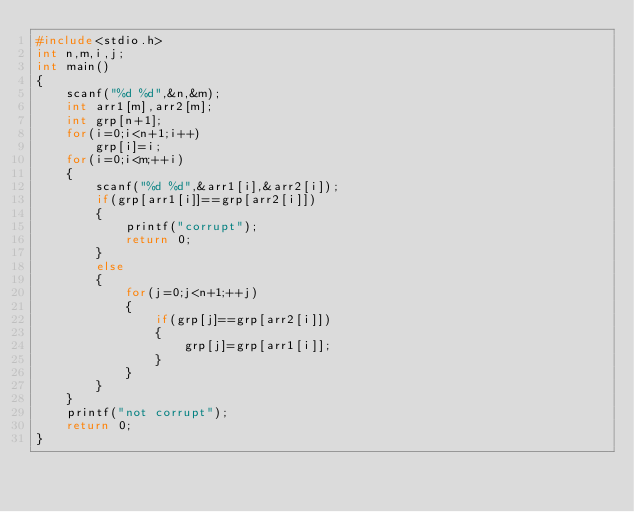<code> <loc_0><loc_0><loc_500><loc_500><_C++_>#include<stdio.h>
int n,m,i,j;
int main()
{
	scanf("%d %d",&n,&m);
	int arr1[m],arr2[m];
	int grp[n+1];
	for(i=0;i<n+1;i++)
		grp[i]=i;
	for(i=0;i<m;++i)
	{
		scanf("%d %d",&arr1[i],&arr2[i]);
		if(grp[arr1[i]]==grp[arr2[i]])
		{
			printf("corrupt");
			return 0;
		}
		else
		{
			for(j=0;j<n+1;++j)
			{
				if(grp[j]==grp[arr2[i]])
				{
					grp[j]=grp[arr1[i]];
				}
			}
		}
	}
	printf("not corrupt");		
	return 0;
}
</code> 